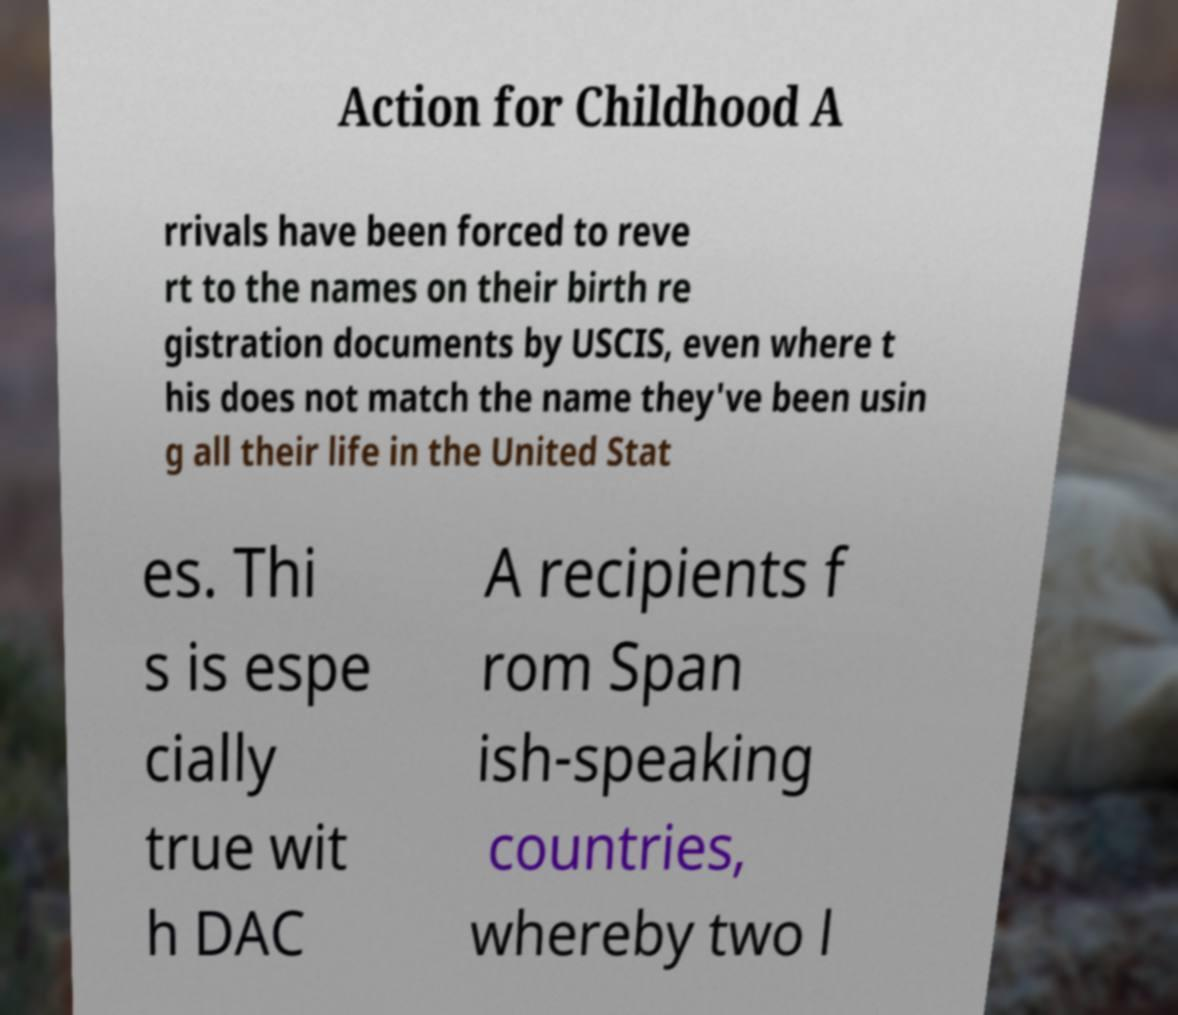Please read and relay the text visible in this image. What does it say? Action for Childhood A rrivals have been forced to reve rt to the names on their birth re gistration documents by USCIS, even where t his does not match the name they've been usin g all their life in the United Stat es. Thi s is espe cially true wit h DAC A recipients f rom Span ish-speaking countries, whereby two l 